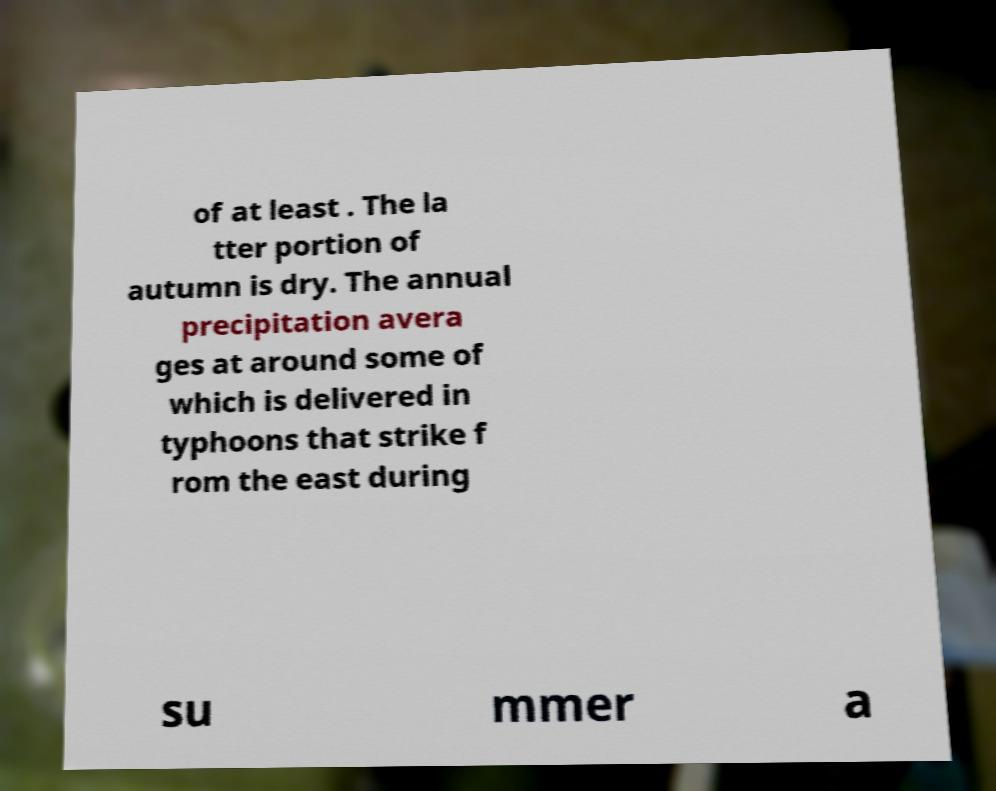There's text embedded in this image that I need extracted. Can you transcribe it verbatim? of at least . The la tter portion of autumn is dry. The annual precipitation avera ges at around some of which is delivered in typhoons that strike f rom the east during su mmer a 